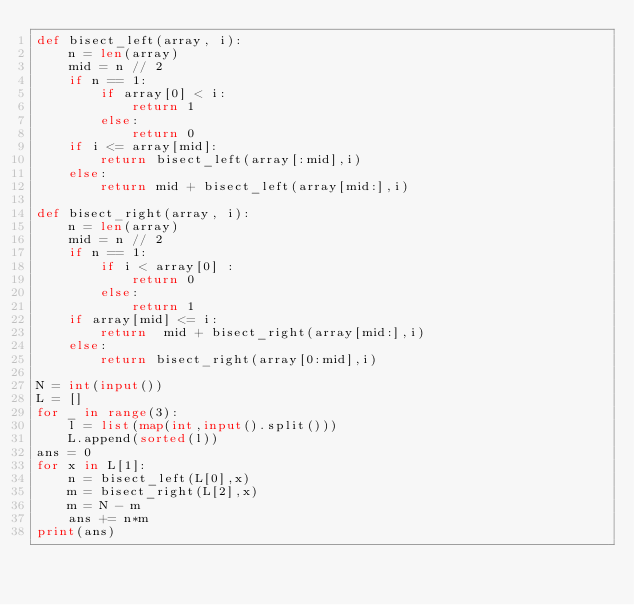Convert code to text. <code><loc_0><loc_0><loc_500><loc_500><_Python_>def bisect_left(array, i):
    n = len(array)
    mid = n // 2
    if n == 1:
        if array[0] < i:
            return 1
        else:
            return 0
    if i <= array[mid]:
        return bisect_left(array[:mid],i)
    else:
        return mid + bisect_left(array[mid:],i)

def bisect_right(array, i):
    n = len(array)
    mid = n // 2
    if n == 1:
        if i < array[0] :
            return 0
        else:
            return 1
    if array[mid] <= i:
        return  mid + bisect_right(array[mid:],i)
    else:
        return bisect_right(array[0:mid],i)

N = int(input())
L = []
for _ in range(3):
    l = list(map(int,input().split()))
    L.append(sorted(l))
ans = 0
for x in L[1]:
    n = bisect_left(L[0],x)
    m = bisect_right(L[2],x)
    m = N - m
    ans += n*m
print(ans)</code> 